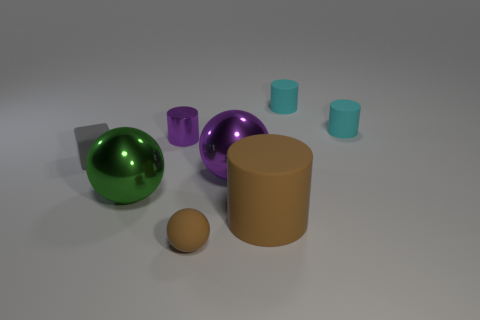Add 1 purple metal things. How many objects exist? 9 Subtract all spheres. How many objects are left? 5 Add 3 large matte objects. How many large matte objects exist? 4 Subtract 0 brown blocks. How many objects are left? 8 Subtract all green matte things. Subtract all large brown matte cylinders. How many objects are left? 7 Add 1 tiny gray rubber blocks. How many tiny gray rubber blocks are left? 2 